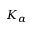<formula> <loc_0><loc_0><loc_500><loc_500>K _ { \alpha }</formula> 